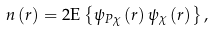Convert formula to latex. <formula><loc_0><loc_0><loc_500><loc_500>n \left ( r \right ) & = 2 \text {E} \left \{ \psi _ { P \chi } \left ( r \right ) \psi _ { \chi } \left ( r \right ) \right \} ,</formula> 